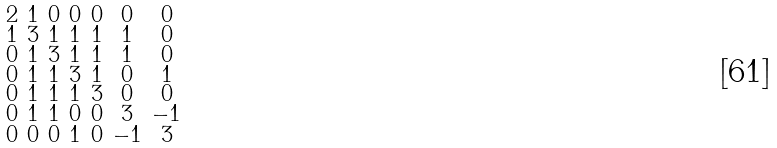<formula> <loc_0><loc_0><loc_500><loc_500>\begin{smallmatrix} 2 & 1 & 0 & 0 & 0 & 0 & 0 \\ 1 & 3 & 1 & 1 & 1 & 1 & 0 \\ 0 & 1 & 3 & 1 & 1 & 1 & 0 \\ 0 & 1 & 1 & 3 & 1 & 0 & 1 \\ 0 & 1 & 1 & 1 & 3 & 0 & 0 \\ 0 & 1 & 1 & 0 & 0 & 3 & - 1 \\ 0 & 0 & 0 & 1 & 0 & - 1 & 3 \end{smallmatrix}</formula> 